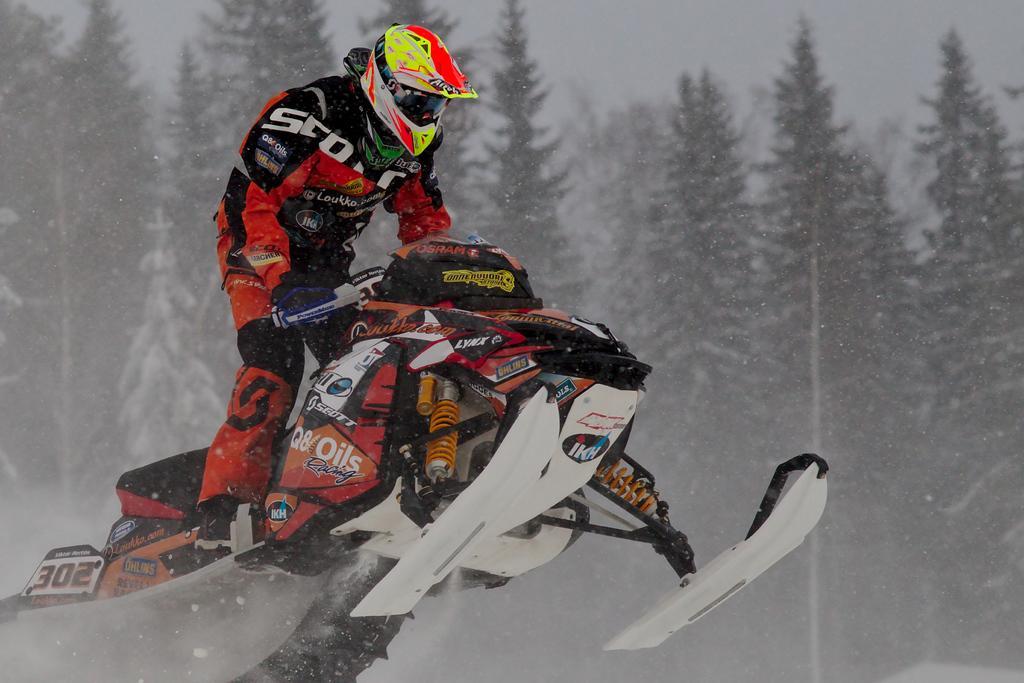Describe this image in one or two sentences. In this picture there is a man who is performing winter sports in the image and there are trees in the background area of the image. 